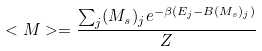<formula> <loc_0><loc_0><loc_500><loc_500>< M > = \frac { \sum _ { j } ( M _ { s } ) _ { j } { e ^ { - \beta ( E _ { j } - B ( M _ { s } ) _ { j } ) } } } { Z }</formula> 